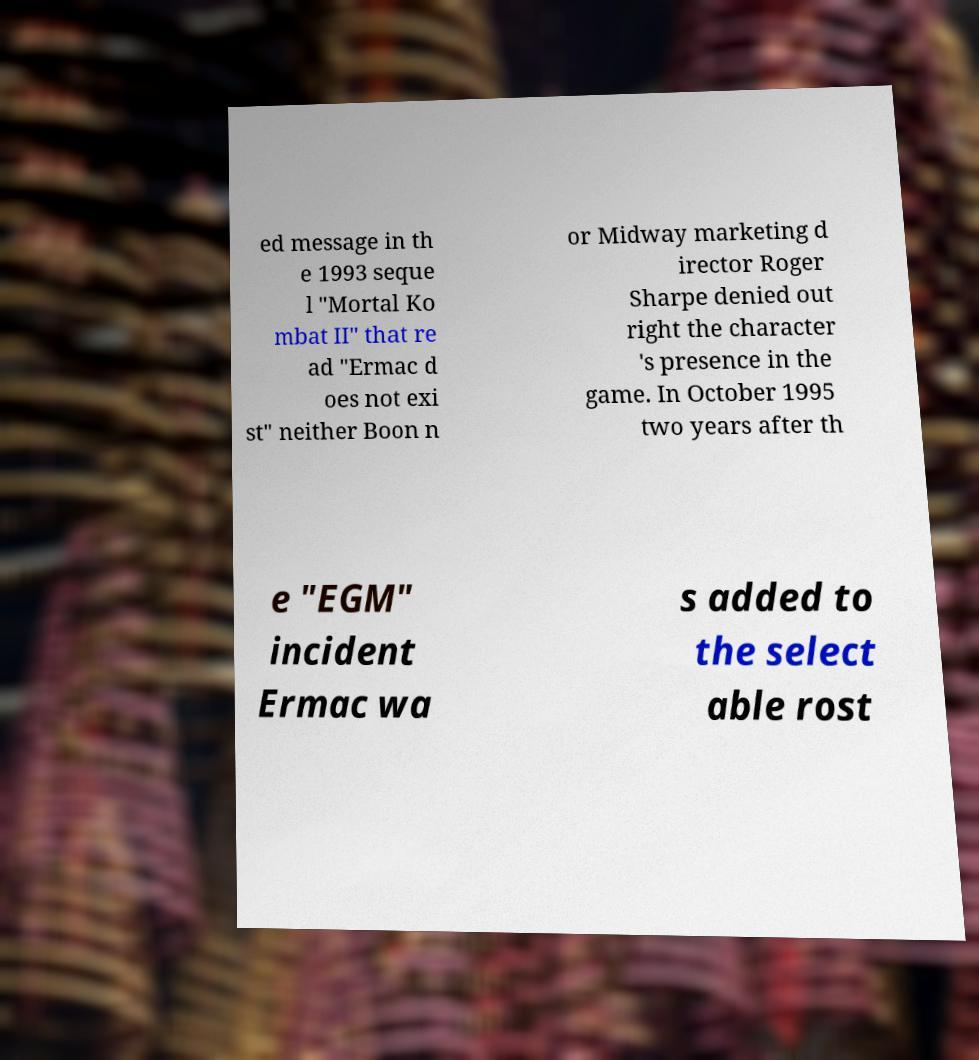Could you extract and type out the text from this image? ed message in th e 1993 seque l "Mortal Ko mbat II" that re ad "Ermac d oes not exi st" neither Boon n or Midway marketing d irector Roger Sharpe denied out right the character 's presence in the game. In October 1995 two years after th e "EGM" incident Ermac wa s added to the select able rost 